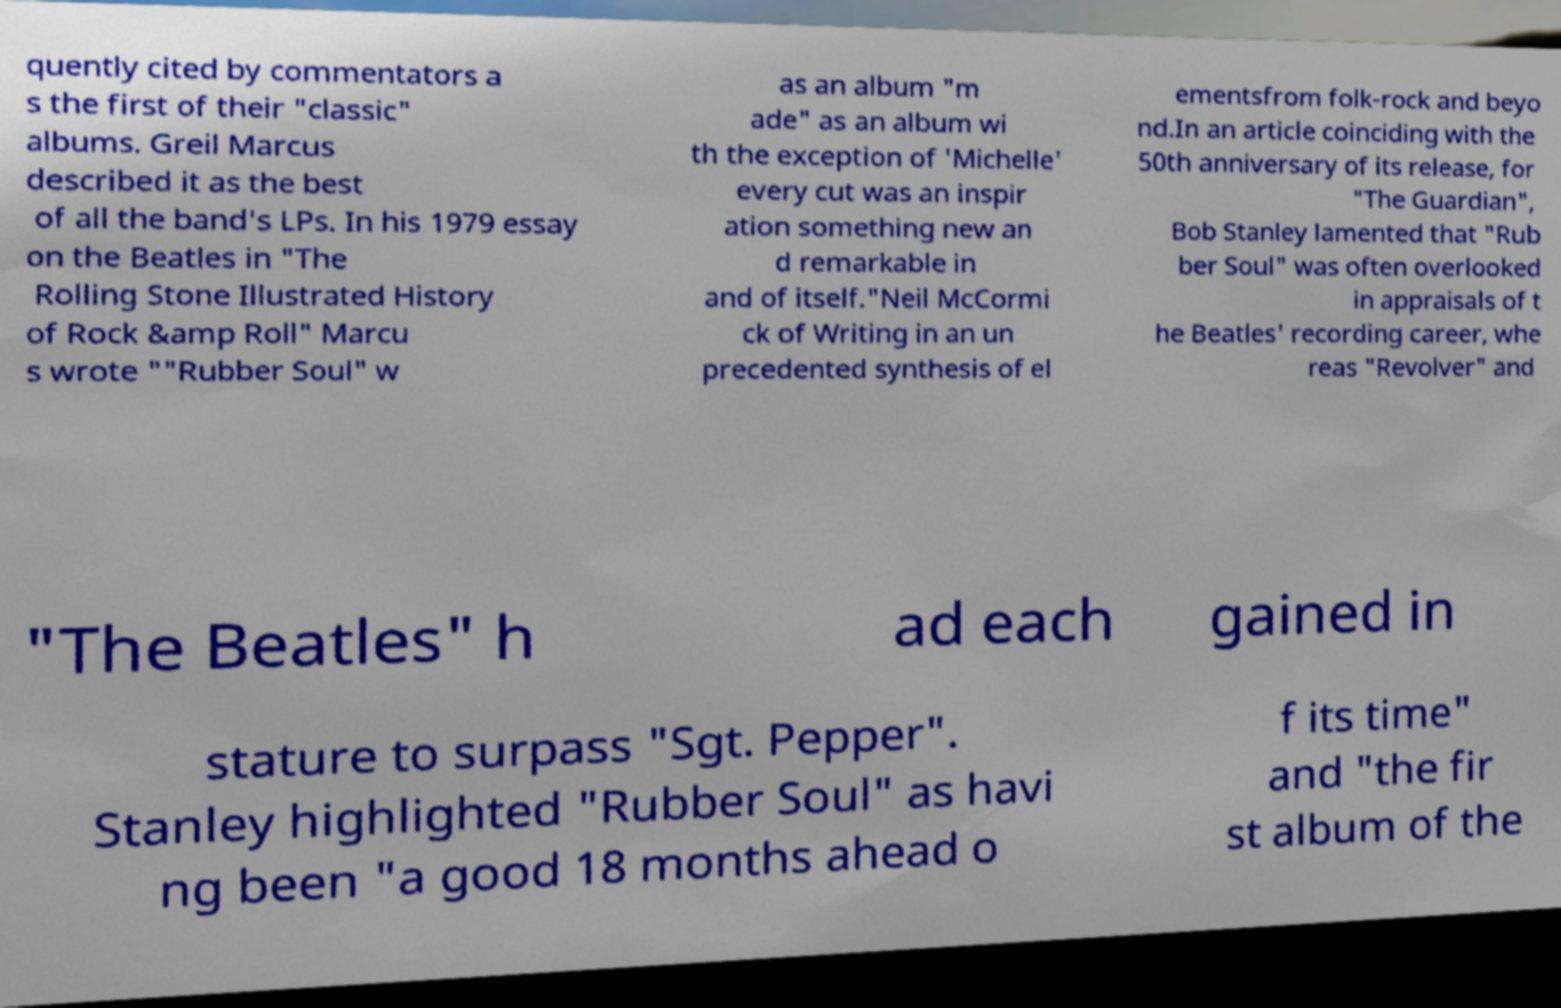Can you accurately transcribe the text from the provided image for me? quently cited by commentators a s the first of their "classic" albums. Greil Marcus described it as the best of all the band's LPs. In his 1979 essay on the Beatles in "The Rolling Stone Illustrated History of Rock &amp Roll" Marcu s wrote ""Rubber Soul" w as an album "m ade" as an album wi th the exception of 'Michelle' every cut was an inspir ation something new an d remarkable in and of itself."Neil McCormi ck of Writing in an un precedented synthesis of el ementsfrom folk-rock and beyo nd.In an article coinciding with the 50th anniversary of its release, for "The Guardian", Bob Stanley lamented that "Rub ber Soul" was often overlooked in appraisals of t he Beatles' recording career, whe reas "Revolver" and "The Beatles" h ad each gained in stature to surpass "Sgt. Pepper". Stanley highlighted "Rubber Soul" as havi ng been "a good 18 months ahead o f its time" and "the fir st album of the 